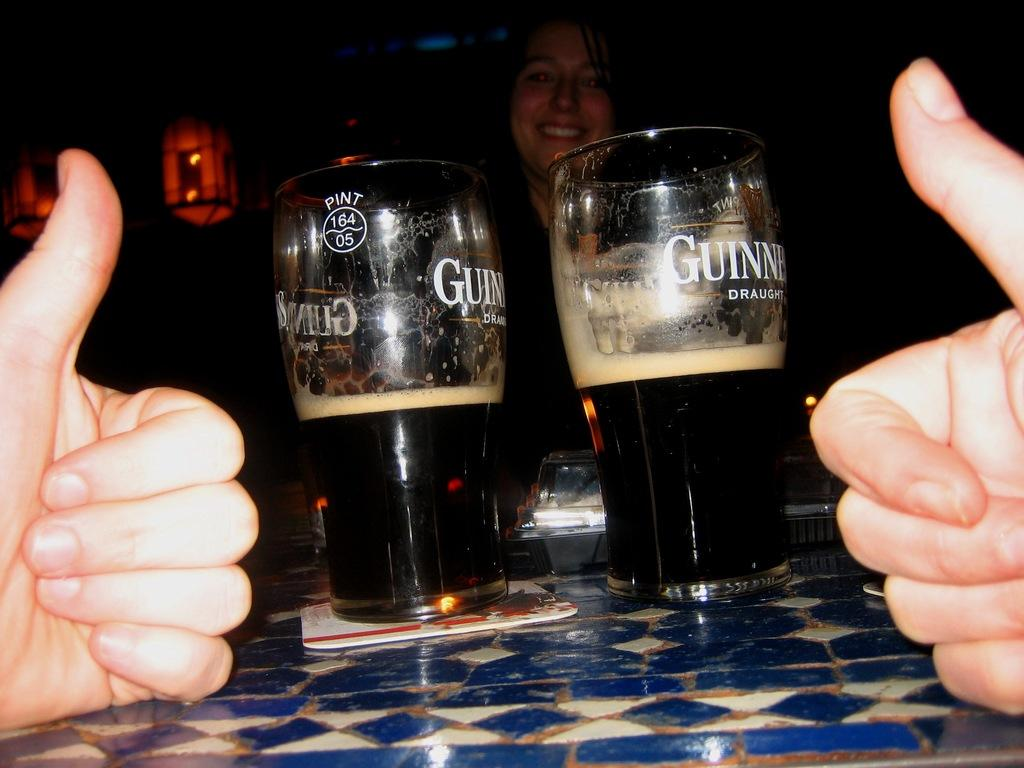<image>
Share a concise interpretation of the image provided. two thumbs up on a bar table with two glasses of Guinness 